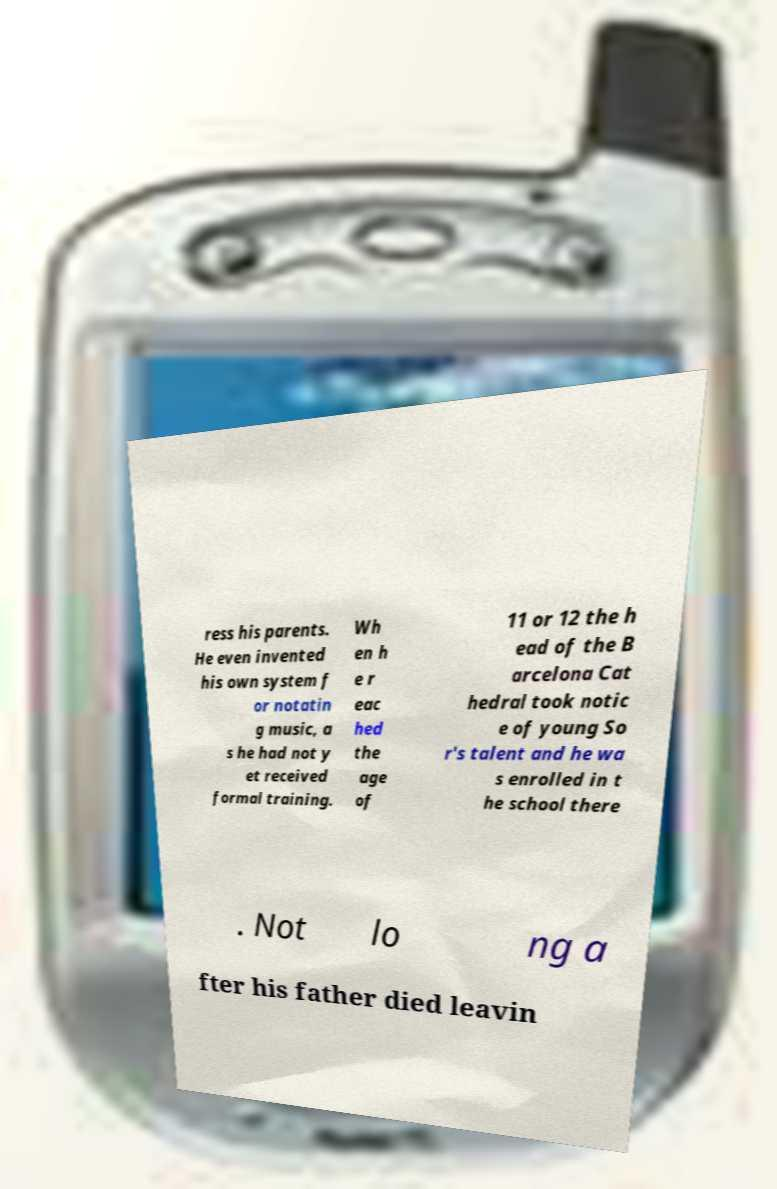I need the written content from this picture converted into text. Can you do that? ress his parents. He even invented his own system f or notatin g music, a s he had not y et received formal training. Wh en h e r eac hed the age of 11 or 12 the h ead of the B arcelona Cat hedral took notic e of young So r's talent and he wa s enrolled in t he school there . Not lo ng a fter his father died leavin 